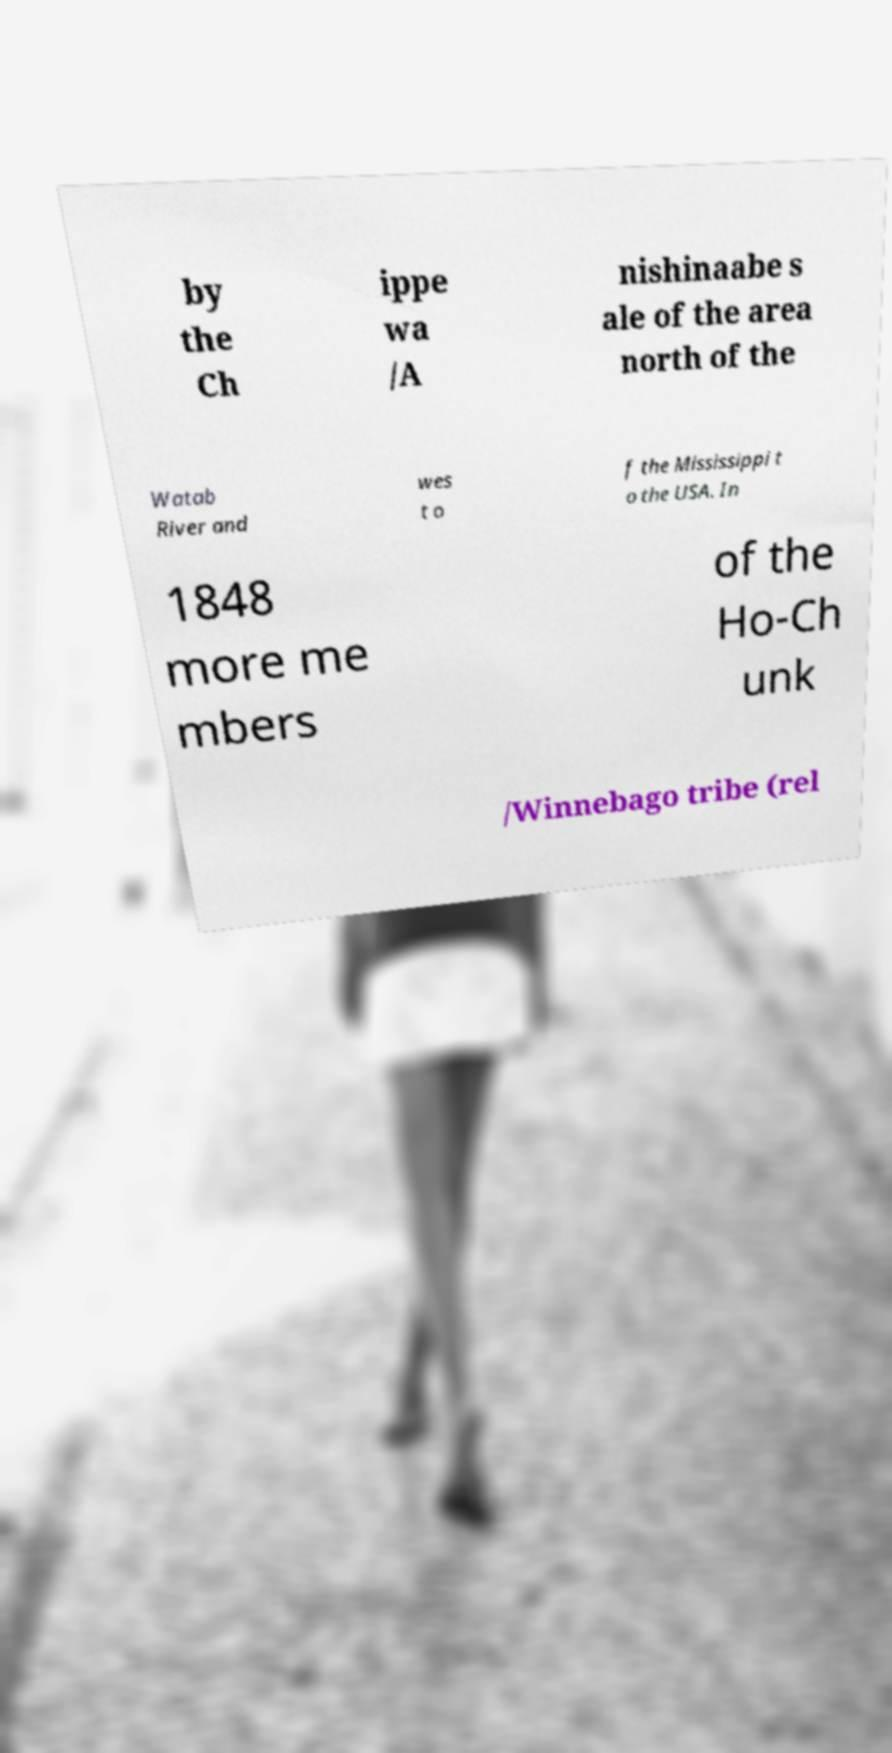What messages or text are displayed in this image? I need them in a readable, typed format. by the Ch ippe wa /A nishinaabe s ale of the area north of the Watab River and wes t o f the Mississippi t o the USA. In 1848 more me mbers of the Ho-Ch unk /Winnebago tribe (rel 